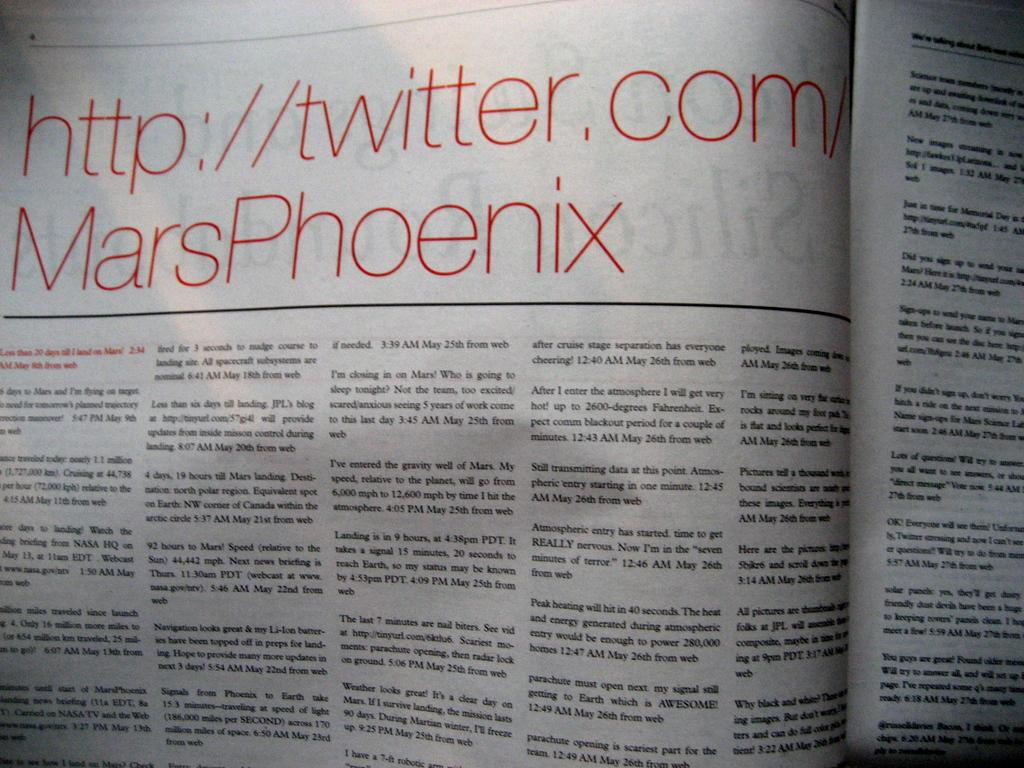<image>
Relay a brief, clear account of the picture shown. A magazine article has "http://twitter.com/MarsPhoenix" as the headline. 